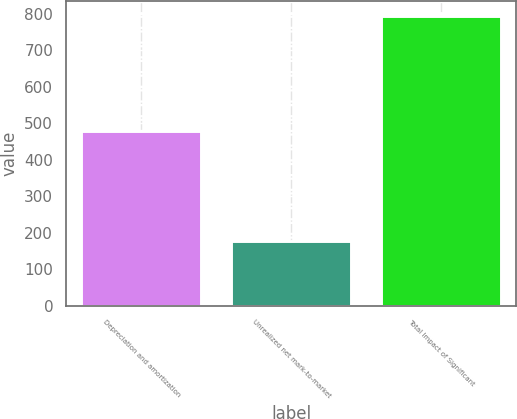Convert chart to OTSL. <chart><loc_0><loc_0><loc_500><loc_500><bar_chart><fcel>Depreciation and amortization<fcel>Unrealized net mark-to-market<fcel>Total Impact of Significant<nl><fcel>480<fcel>176<fcel>795<nl></chart> 